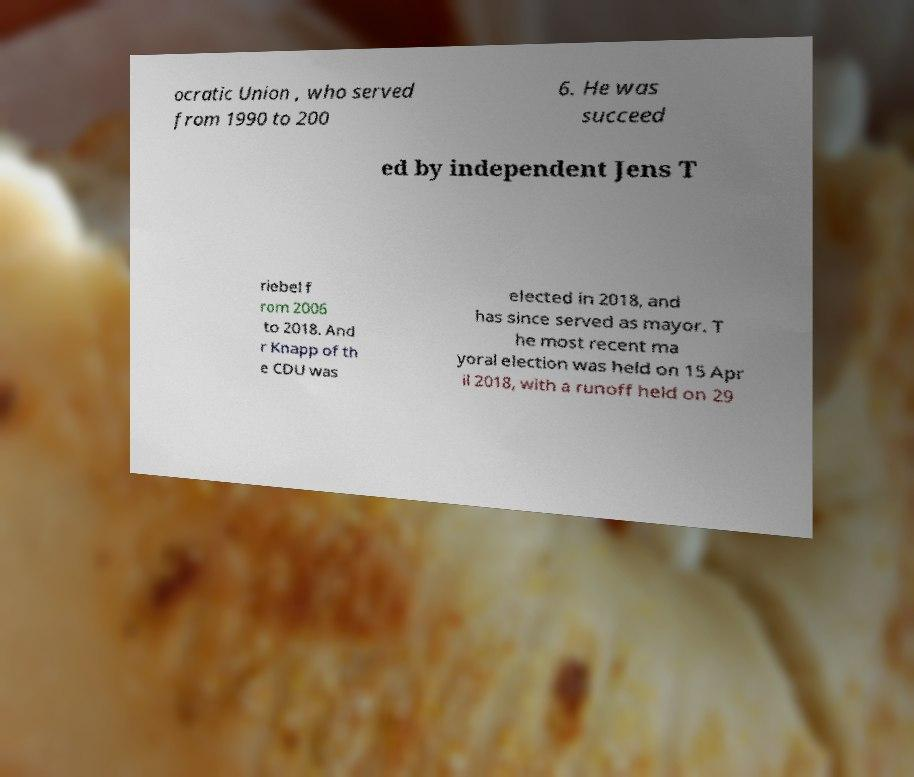Can you read and provide the text displayed in the image?This photo seems to have some interesting text. Can you extract and type it out for me? ocratic Union , who served from 1990 to 200 6. He was succeed ed by independent Jens T riebel f rom 2006 to 2018. And r Knapp of th e CDU was elected in 2018, and has since served as mayor. T he most recent ma yoral election was held on 15 Apr il 2018, with a runoff held on 29 